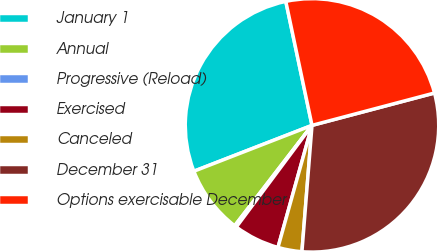Convert chart to OTSL. <chart><loc_0><loc_0><loc_500><loc_500><pie_chart><fcel>January 1<fcel>Annual<fcel>Progressive (Reload)<fcel>Exercised<fcel>Canceled<fcel>December 31<fcel>Options exercisable December<nl><fcel>27.58%<fcel>8.66%<fcel>0.26%<fcel>5.86%<fcel>3.06%<fcel>30.38%<fcel>24.2%<nl></chart> 